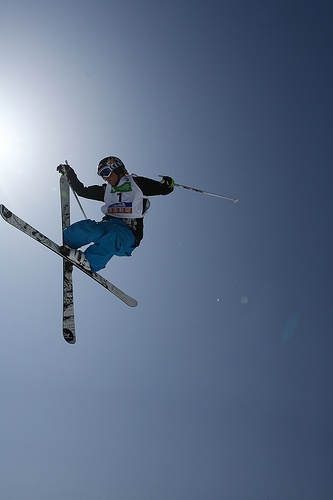Describe the objects in this image and their specific colors. I can see people in gray, black, and darkblue tones and skis in gray, black, and darkgray tones in this image. 